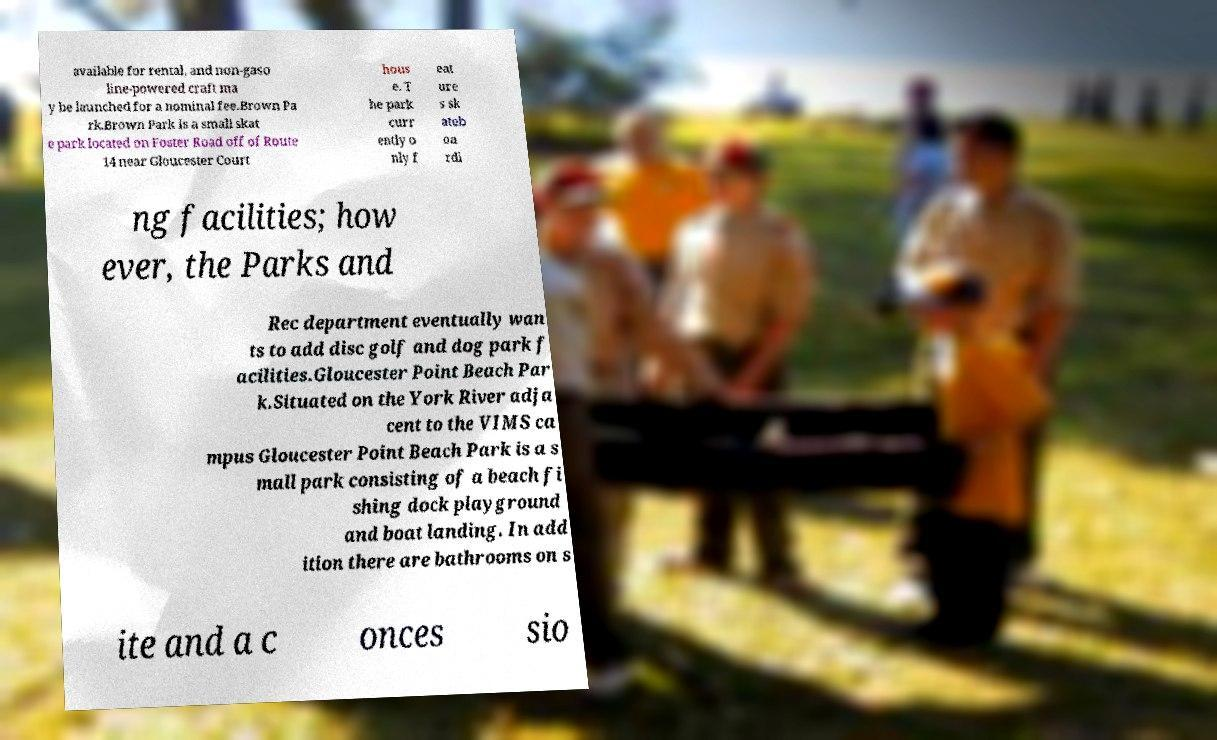I need the written content from this picture converted into text. Can you do that? available for rental, and non-gaso line-powered craft ma y be launched for a nominal fee.Brown Pa rk.Brown Park is a small skat e park located on Foster Road off of Route 14 near Gloucester Court hous e. T he park curr ently o nly f eat ure s sk ateb oa rdi ng facilities; how ever, the Parks and Rec department eventually wan ts to add disc golf and dog park f acilities.Gloucester Point Beach Par k.Situated on the York River adja cent to the VIMS ca mpus Gloucester Point Beach Park is a s mall park consisting of a beach fi shing dock playground and boat landing. In add ition there are bathrooms on s ite and a c onces sio 